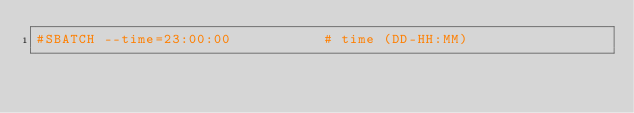Convert code to text. <code><loc_0><loc_0><loc_500><loc_500><_Bash_>#SBATCH --time=23:00:00           # time (DD-HH:MM)</code> 